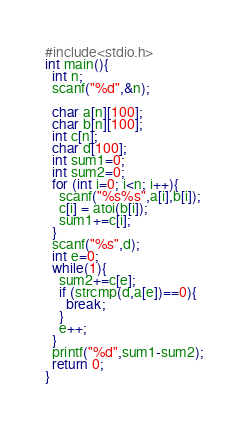Convert code to text. <code><loc_0><loc_0><loc_500><loc_500><_C_>#include<stdio.h>
int main(){
  int n;
  scanf("%d",&n);
	
  char a[n][100];
  char b[n][100];
  int c[n];
  char d[100];
  int sum1=0;
  int sum2=0;
  for (int i=0; i<n; i++){
    scanf("%s%s",a[i],b[i]);
    c[i] = atoi(b[i]);
    sum1+=c[i];
  }
  scanf("%s",d);
  int e=0;
  while(1){
    sum2+=c[e];
    if (strcmp(d,a[e])==0){
      break;
    }
    e++;
  }
  printf("%d",sum1-sum2);
  return 0;
}</code> 